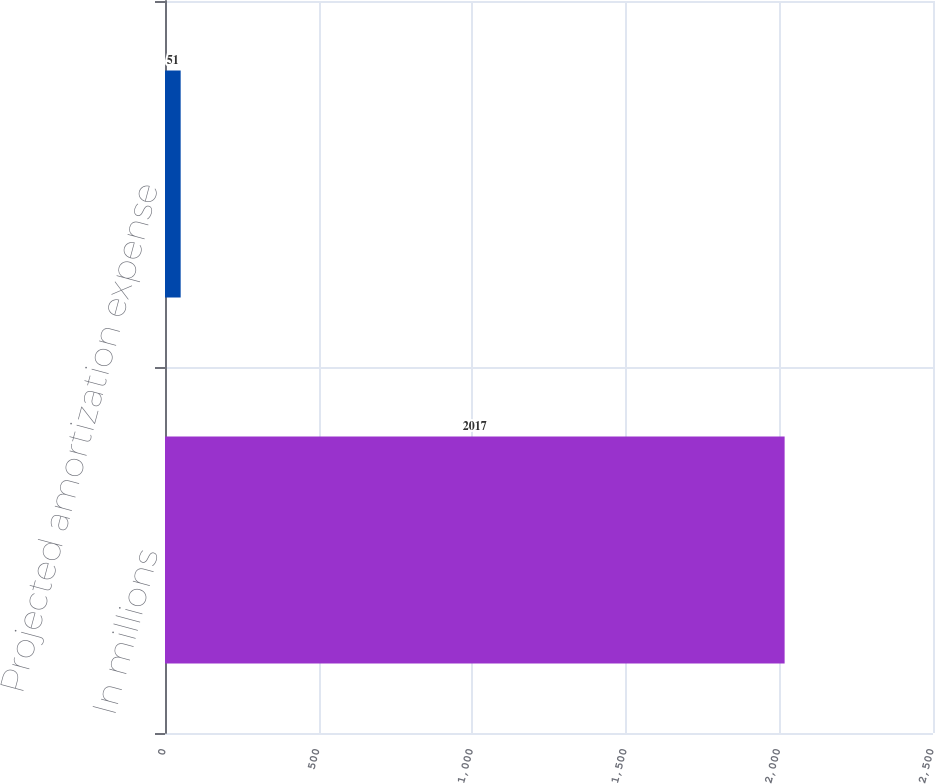Convert chart. <chart><loc_0><loc_0><loc_500><loc_500><bar_chart><fcel>In millions<fcel>Projected amortization expense<nl><fcel>2017<fcel>51<nl></chart> 